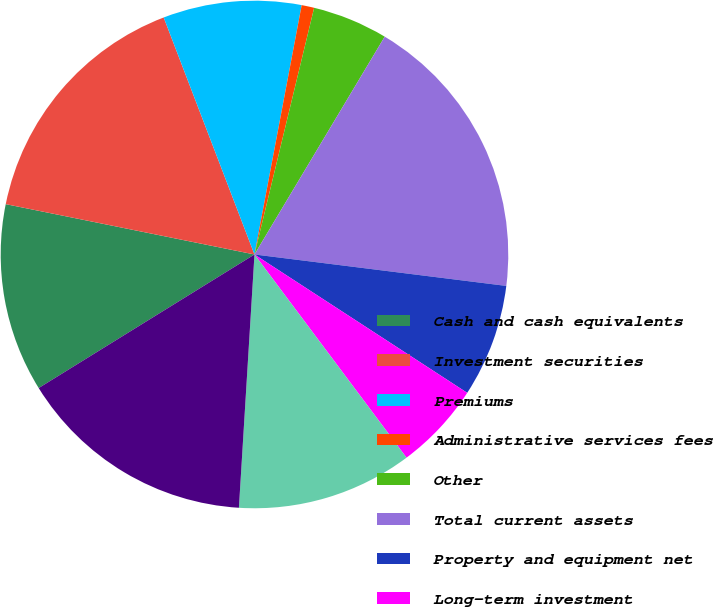Convert chart. <chart><loc_0><loc_0><loc_500><loc_500><pie_chart><fcel>Cash and cash equivalents<fcel>Investment securities<fcel>Premiums<fcel>Administrative services fees<fcel>Other<fcel>Total current assets<fcel>Property and equipment net<fcel>Long-term investment<fcel>Goodwill<fcel>Total other assets<nl><fcel>12.0%<fcel>16.0%<fcel>8.8%<fcel>0.8%<fcel>4.8%<fcel>18.4%<fcel>7.2%<fcel>5.6%<fcel>11.2%<fcel>15.2%<nl></chart> 